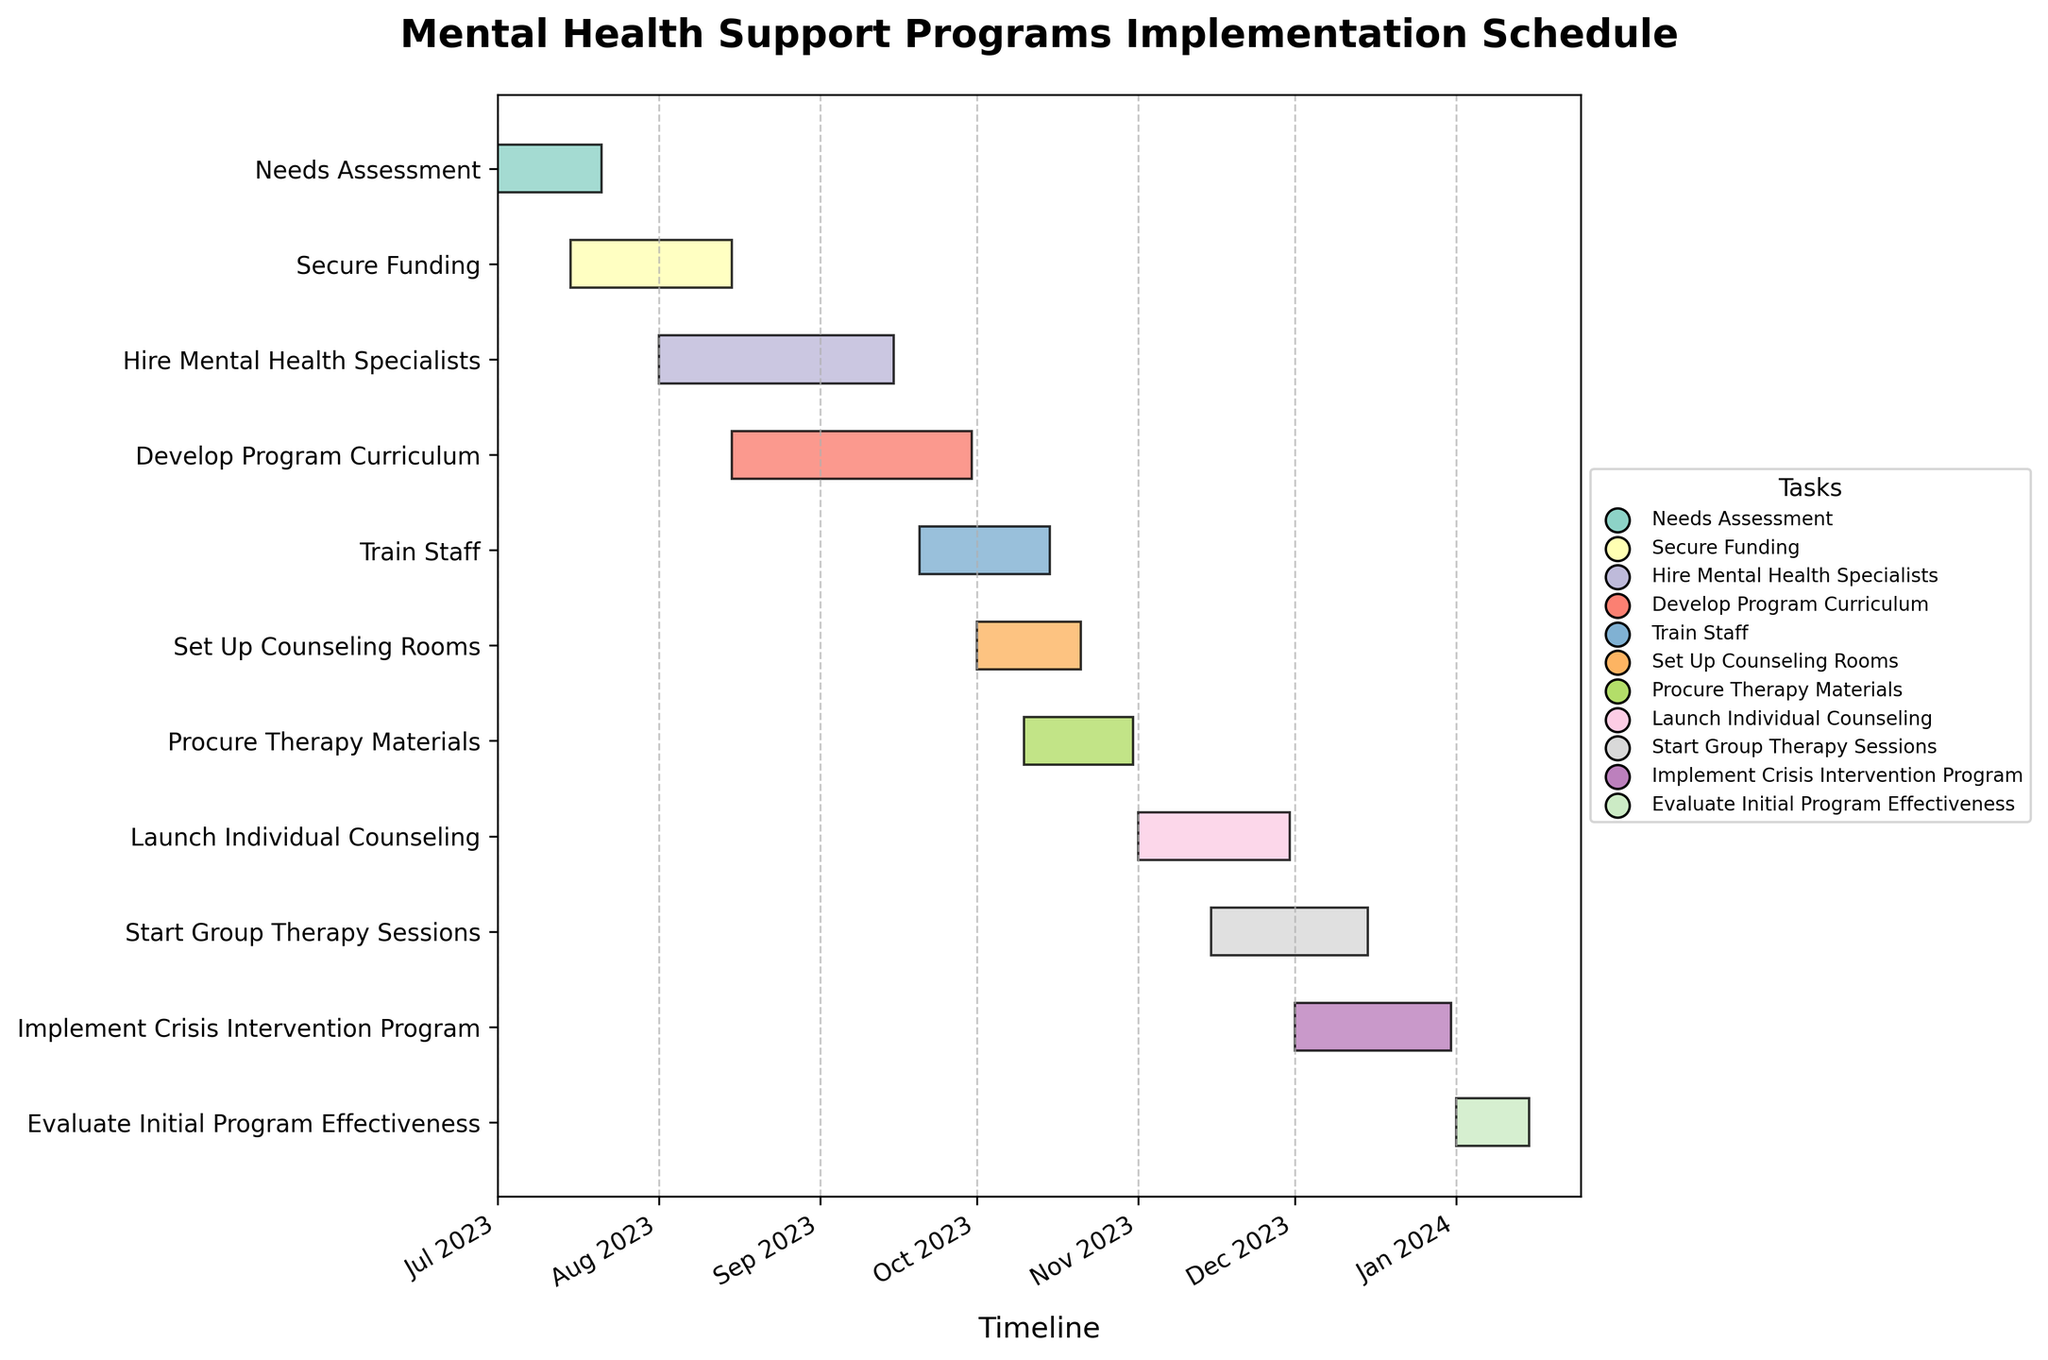What's the title of the Gantt chart? The title is generally located at the top of the chart. It provides a brief description of the chart's content. From the data and code provided, the title is clearly stated: "Mental Health Support Programs Implementation Schedule."
Answer: Mental Health Support Programs Implementation Schedule How many tasks are displayed in the figure? To determine the number of tasks, one needs to count each unique task listed on the vertical axis. The data provides a total of 11 tasks.
Answer: 11 Which task starts first? The first task can be identified by looking for the earliest start date on the horizontal timeline. In this chart, the earliest start date is July 1, 2023, for the task "Needs Assessment."
Answer: Needs Assessment What is the duration of the "Hire Mental Health Specialists" task? The duration of this task is determined by subtracting the start date from the end date: August 1, 2023, to September 15, 2023. This difference equals 45 days.
Answer: 45 days How many tasks are scheduled to start in October 2023? To answer this, identify all tasks with a start date falling within October 2023. From the data, these tasks are "Set Up Counseling Rooms" and "Procure Therapy Materials."
Answer: 2 Which task ends last? The last task is indicated by the furthest end date on the horizontal timeline. For this chart, "Evaluate Initial Program Effectiveness" ends on January 15, 2024.
Answer: Evaluate Initial Program Effectiveness Are there any tasks that overlap entirely in their duration? Check for tasks with overlapping start and end dates. Notice that "Train Staff" (September 20 – October 15) overlaps with the end of "Develop Program Curriculum" (August 15 – September 30) and "Set Up Counseling Rooms" (October 1 – October 21), but not entirely within their durations. Thus, no tasks overlap entirely.
Answer: No What is the total duration from the start of the first task to the end of the last task? Calculate the period from the start of "Needs Assessment" on July 1, 2023, to the end of "Evaluate Initial Program Effectiveness" on January 15, 2024. This duration is 199 days.
Answer: 199 days Which tasks are scheduled to run concurrently in November 2023? Identify tasks with overlapping durations in November 2023. These tasks are "Launch Individual Counseling" (November 1 – November 30) and "Start Group Therapy Sessions" (November 15 – December 15).
Answer: Launch Individual Counseling and Start Group Therapy Sessions What tasks are necessary to complete before "Launch Individual Counseling" can start? Review the tasks that end before November 1, 2023, which is the start of "Launch Individual Counseling." These tasks include "Needs Assessment," "Secure Funding," "Hire Mental Health Specialists," "Develop Program Curriculum," "Train Staff," "Set Up Counseling Rooms," and "Procure Therapy Materials."
Answer: Needs Assessment, Secure Funding, Hire Mental Health Specialists, Develop Program Curriculum, Train Staff, Set Up Counseling Rooms, and Procure Therapy Materials 